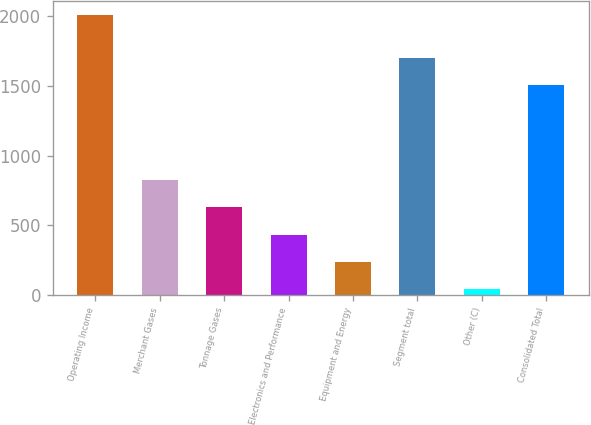<chart> <loc_0><loc_0><loc_500><loc_500><bar_chart><fcel>Operating Income<fcel>Merchant Gases<fcel>Tonnage Gases<fcel>Electronics and Performance<fcel>Equipment and Energy<fcel>Segment total<fcel>Other (C)<fcel>Consolidated Total<nl><fcel>2011<fcel>827.98<fcel>630.81<fcel>433.64<fcel>236.47<fcel>1705.27<fcel>39.3<fcel>1508.1<nl></chart> 